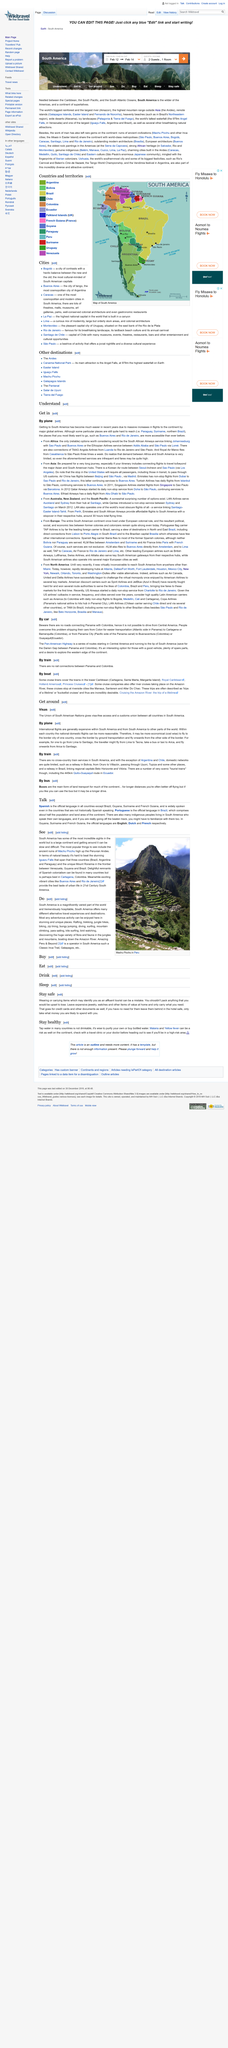Specify some key components in this picture. The world's tallest waterfall can be found in South America. Iguazu Falls are located in three countries, namely Brazil, Argentina, and Paraguay. The Vendimia festival takes place in Argentina. To stay safe, it is recommended in this text to avoid wearing or carrying items that identify you as an affluent tourist and to leave any valuables at home. Instead, only carry the things you really need and would not be upset to lose. The ancient ruins of Machu Picchu, located high in the Peruvian Andes, are the most popular tourist attractions in South America. 